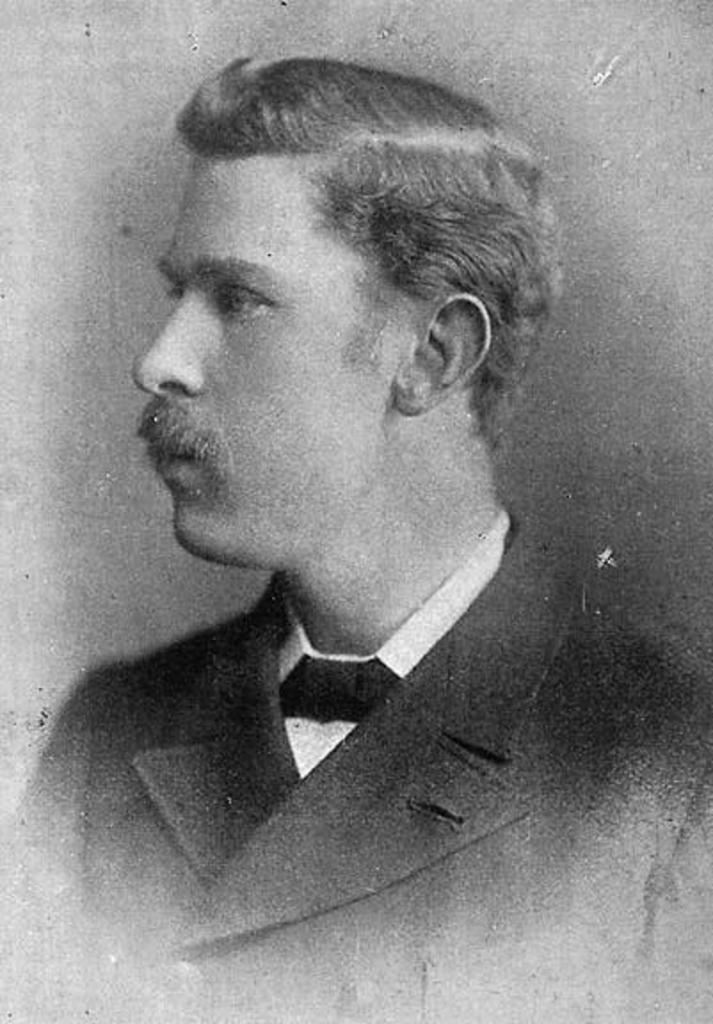Who is present in the image? There is a man in the image. What is the man wearing? The man is wearing a black suit, a white shirt, and a black tie. How many cats are playing with the children in the image? There are no cats or children present in the image; it only features a man wearing a black suit, a white shirt, and a black tie. 